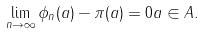Convert formula to latex. <formula><loc_0><loc_0><loc_500><loc_500>\lim _ { n \to \infty } \| \phi _ { n } ( a ) - \pi ( a ) \| = 0 a \in A .</formula> 